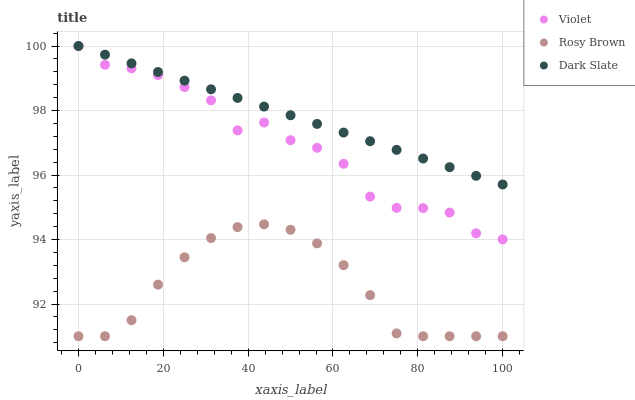Does Rosy Brown have the minimum area under the curve?
Answer yes or no. Yes. Does Dark Slate have the maximum area under the curve?
Answer yes or no. Yes. Does Violet have the minimum area under the curve?
Answer yes or no. No. Does Violet have the maximum area under the curve?
Answer yes or no. No. Is Dark Slate the smoothest?
Answer yes or no. Yes. Is Violet the roughest?
Answer yes or no. Yes. Is Rosy Brown the smoothest?
Answer yes or no. No. Is Rosy Brown the roughest?
Answer yes or no. No. Does Rosy Brown have the lowest value?
Answer yes or no. Yes. Does Violet have the lowest value?
Answer yes or no. No. Does Violet have the highest value?
Answer yes or no. Yes. Does Rosy Brown have the highest value?
Answer yes or no. No. Is Rosy Brown less than Dark Slate?
Answer yes or no. Yes. Is Dark Slate greater than Rosy Brown?
Answer yes or no. Yes. Does Dark Slate intersect Violet?
Answer yes or no. Yes. Is Dark Slate less than Violet?
Answer yes or no. No. Is Dark Slate greater than Violet?
Answer yes or no. No. Does Rosy Brown intersect Dark Slate?
Answer yes or no. No. 